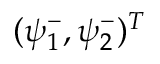<formula> <loc_0><loc_0><loc_500><loc_500>( \psi _ { 1 } ^ { - } , \psi _ { 2 } ^ { - } ) ^ { T }</formula> 